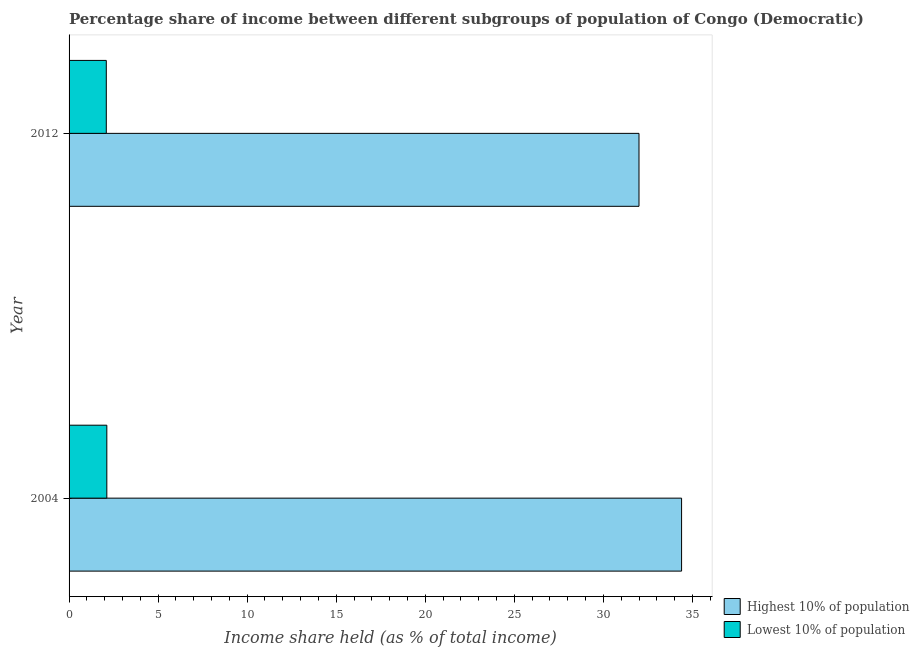How many different coloured bars are there?
Offer a very short reply. 2. How many groups of bars are there?
Give a very brief answer. 2. Are the number of bars per tick equal to the number of legend labels?
Your response must be concise. Yes. How many bars are there on the 1st tick from the top?
Your answer should be compact. 2. What is the label of the 1st group of bars from the top?
Provide a short and direct response. 2012. Across all years, what is the maximum income share held by lowest 10% of the population?
Your answer should be very brief. 2.12. Across all years, what is the minimum income share held by lowest 10% of the population?
Your response must be concise. 2.09. In which year was the income share held by highest 10% of the population maximum?
Your answer should be compact. 2004. What is the total income share held by highest 10% of the population in the graph?
Ensure brevity in your answer.  66.39. What is the difference between the income share held by lowest 10% of the population in 2004 and that in 2012?
Make the answer very short. 0.03. What is the difference between the income share held by lowest 10% of the population in 2012 and the income share held by highest 10% of the population in 2004?
Make the answer very short. -32.3. What is the average income share held by highest 10% of the population per year?
Give a very brief answer. 33.2. In the year 2004, what is the difference between the income share held by highest 10% of the population and income share held by lowest 10% of the population?
Offer a terse response. 32.27. In how many years, is the income share held by highest 10% of the population greater than 3 %?
Offer a very short reply. 2. What is the ratio of the income share held by highest 10% of the population in 2004 to that in 2012?
Give a very brief answer. 1.07. In how many years, is the income share held by lowest 10% of the population greater than the average income share held by lowest 10% of the population taken over all years?
Offer a terse response. 1. What does the 1st bar from the top in 2004 represents?
Your response must be concise. Lowest 10% of population. What does the 1st bar from the bottom in 2012 represents?
Provide a short and direct response. Highest 10% of population. What is the difference between two consecutive major ticks on the X-axis?
Keep it short and to the point. 5. Are the values on the major ticks of X-axis written in scientific E-notation?
Make the answer very short. No. Does the graph contain any zero values?
Your answer should be compact. No. Does the graph contain grids?
Provide a succinct answer. No. How many legend labels are there?
Provide a succinct answer. 2. How are the legend labels stacked?
Offer a terse response. Vertical. What is the title of the graph?
Provide a short and direct response. Percentage share of income between different subgroups of population of Congo (Democratic). Does "Public funds" appear as one of the legend labels in the graph?
Provide a short and direct response. No. What is the label or title of the X-axis?
Your response must be concise. Income share held (as % of total income). What is the Income share held (as % of total income) in Highest 10% of population in 2004?
Provide a succinct answer. 34.39. What is the Income share held (as % of total income) of Lowest 10% of population in 2004?
Make the answer very short. 2.12. What is the Income share held (as % of total income) in Lowest 10% of population in 2012?
Your response must be concise. 2.09. Across all years, what is the maximum Income share held (as % of total income) of Highest 10% of population?
Provide a short and direct response. 34.39. Across all years, what is the maximum Income share held (as % of total income) in Lowest 10% of population?
Your response must be concise. 2.12. Across all years, what is the minimum Income share held (as % of total income) in Highest 10% of population?
Your answer should be very brief. 32. Across all years, what is the minimum Income share held (as % of total income) in Lowest 10% of population?
Offer a very short reply. 2.09. What is the total Income share held (as % of total income) in Highest 10% of population in the graph?
Give a very brief answer. 66.39. What is the total Income share held (as % of total income) of Lowest 10% of population in the graph?
Your answer should be very brief. 4.21. What is the difference between the Income share held (as % of total income) of Highest 10% of population in 2004 and that in 2012?
Keep it short and to the point. 2.39. What is the difference between the Income share held (as % of total income) in Lowest 10% of population in 2004 and that in 2012?
Provide a short and direct response. 0.03. What is the difference between the Income share held (as % of total income) of Highest 10% of population in 2004 and the Income share held (as % of total income) of Lowest 10% of population in 2012?
Make the answer very short. 32.3. What is the average Income share held (as % of total income) in Highest 10% of population per year?
Provide a succinct answer. 33.2. What is the average Income share held (as % of total income) of Lowest 10% of population per year?
Ensure brevity in your answer.  2.1. In the year 2004, what is the difference between the Income share held (as % of total income) of Highest 10% of population and Income share held (as % of total income) of Lowest 10% of population?
Provide a succinct answer. 32.27. In the year 2012, what is the difference between the Income share held (as % of total income) in Highest 10% of population and Income share held (as % of total income) in Lowest 10% of population?
Ensure brevity in your answer.  29.91. What is the ratio of the Income share held (as % of total income) of Highest 10% of population in 2004 to that in 2012?
Offer a terse response. 1.07. What is the ratio of the Income share held (as % of total income) of Lowest 10% of population in 2004 to that in 2012?
Your answer should be compact. 1.01. What is the difference between the highest and the second highest Income share held (as % of total income) in Highest 10% of population?
Offer a very short reply. 2.39. What is the difference between the highest and the second highest Income share held (as % of total income) of Lowest 10% of population?
Offer a terse response. 0.03. What is the difference between the highest and the lowest Income share held (as % of total income) of Highest 10% of population?
Offer a very short reply. 2.39. What is the difference between the highest and the lowest Income share held (as % of total income) of Lowest 10% of population?
Provide a succinct answer. 0.03. 